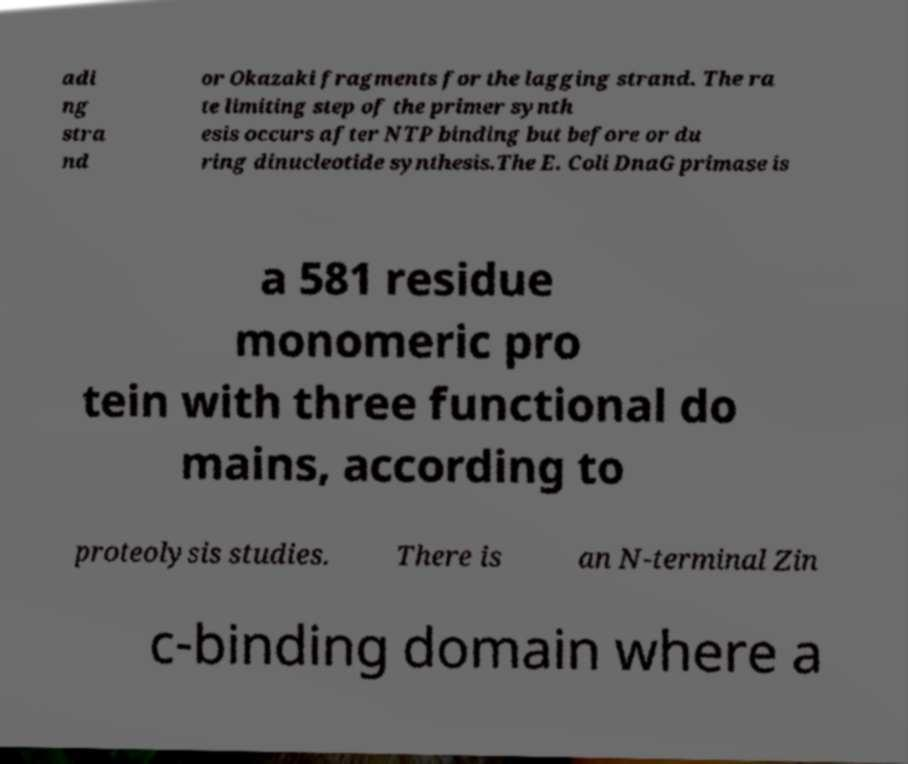Could you extract and type out the text from this image? adi ng stra nd or Okazaki fragments for the lagging strand. The ra te limiting step of the primer synth esis occurs after NTP binding but before or du ring dinucleotide synthesis.The E. Coli DnaG primase is a 581 residue monomeric pro tein with three functional do mains, according to proteolysis studies. There is an N-terminal Zin c-binding domain where a 